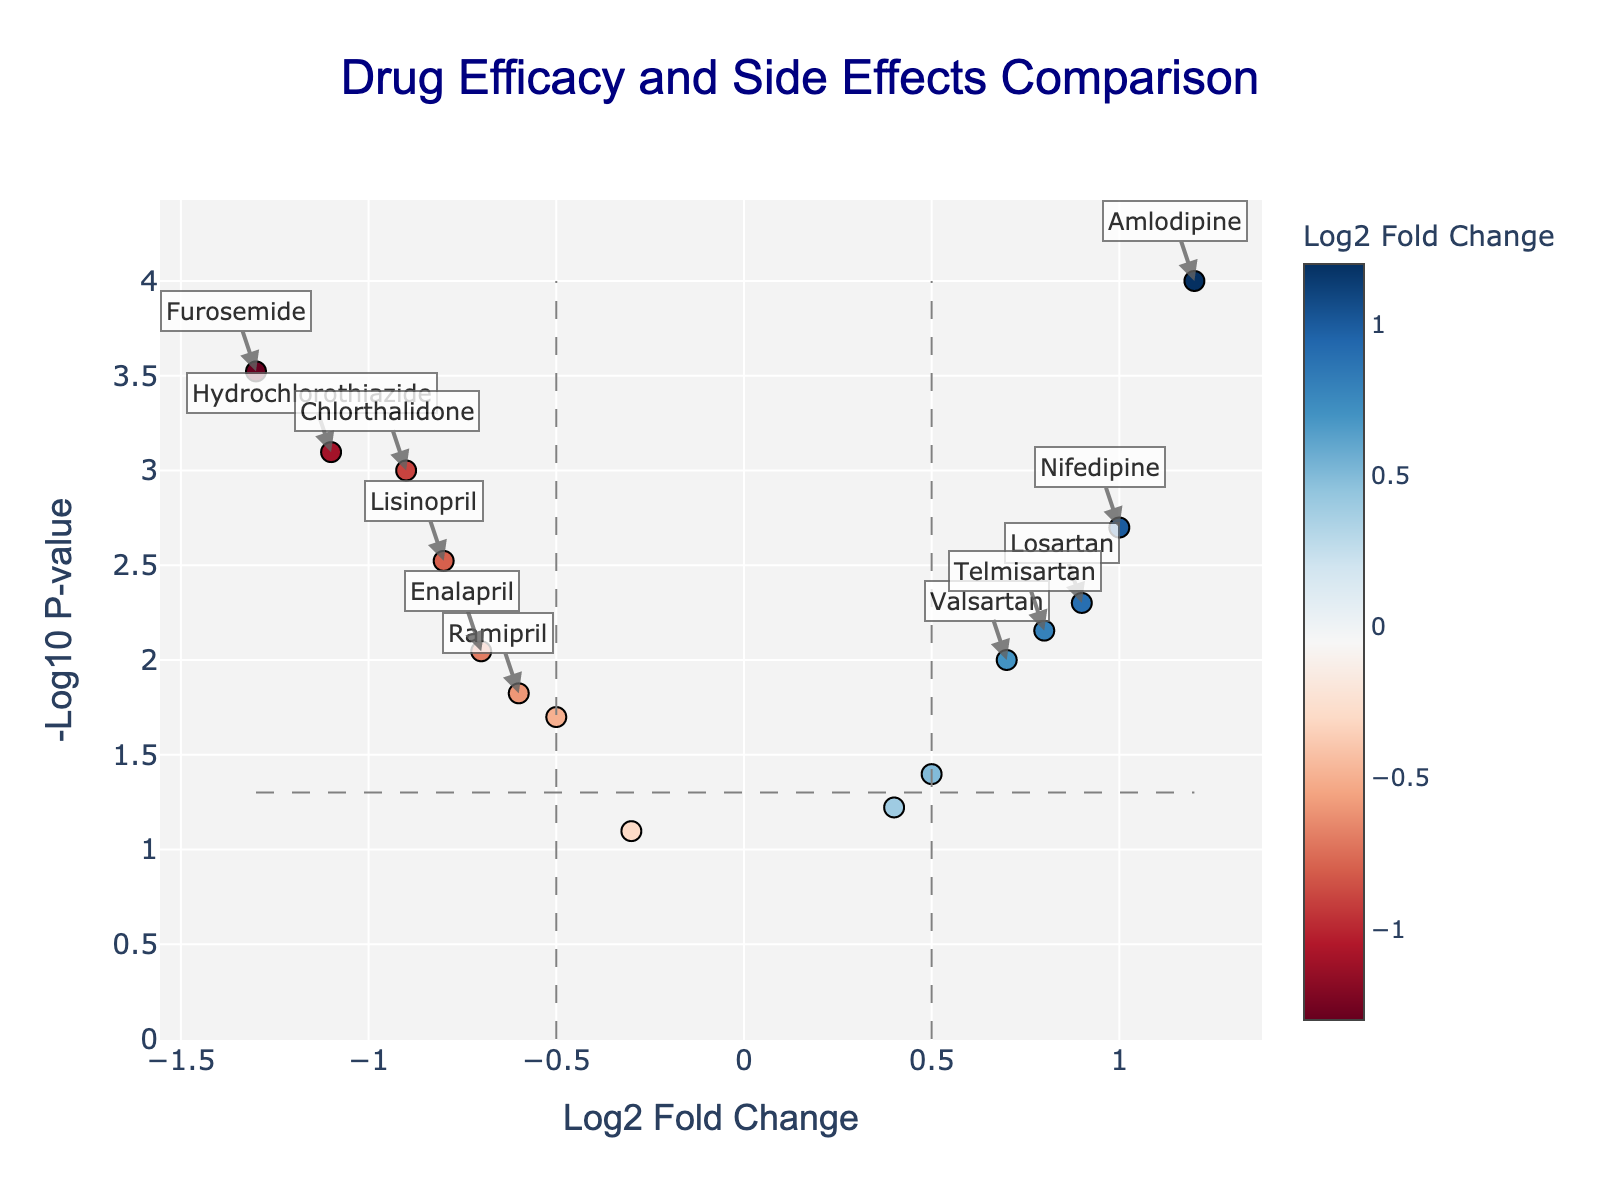What's the title of the plot? The title is typically displayed prominently at the top of the plot. You can directly read the title from that position.
Answer: Drug Efficacy and Side Effects Comparison Which drug has the highest Log2 Fold Change? To determine the highest Log2 Fold Change, look for the data point farthest to the right along the x-axis. In this plot, the drug with the highest Log2 Fold Change value is the one marked 1.2.
Answer: Amlodipine How many drugs have a p-value less than 0.05? To find the drugs with a p-value less than 0.05, check for points above the horizontal significance line (y = -log10(0.05)). Count these points.
Answer: 11 What's the Log2 Fold Change and p-value of Furosemide? Hover over the data point for Furosemide or find its label to identify its position. The provided data shows Furosemide with a Log2 Fold Change of -1.3 and p-value of 0.0003.
Answer: Log2 Fold Change: -1.3, p-value: 0.0003 Which drugs are labeled as significant based on the criteria in the plot? Drugs labeled as significant have a Log2 Fold Change greater than 0.5 or less than -0.5, and a p-value less than 0.05. From the plot, these drugs will be annotated.
Answer: Lisinopril, Amlodipine, Losartan, Hydrochlorothiazide, Nifedipine, Telmisartan, Enalapril, Furosemide, Chlorthalidone Which drug shows the most significant p-value? The most significant p-value corresponds to the highest -log10(p-value) on the y-axis. The point at the highest vertical position represents this drug.
Answer: Amlodipine Compare the p-values of Lisinopril and Ramipril. Which one is more significant? To compare the p-values, look at the y-axis positions of the points for Lisinopril and Ramipril. The higher the -log10(p-value), the more significant the p-value. Lisinopril appears higher on the plot.
Answer: Lisinopril What is the Log2 Fold Change range of the plotted drugs? Check the minimum and maximum points along the x-axis to determine the range. The minimum is -1.3 (for Furosemide) and the maximum is 1.2 (for Amlodipine).
Answer: Range: -1.3 to 1.2 How many drugs have negative Log2 Fold Change values? Count the number of points to the left of the vertical line x=0, as these represent negative Log2 Fold Change values.
Answer: 7 